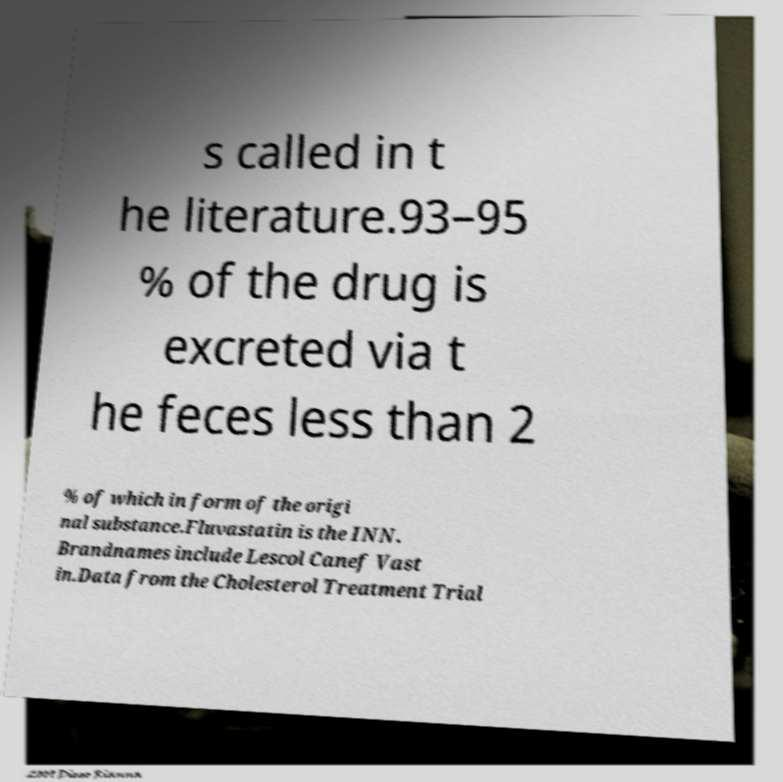I need the written content from this picture converted into text. Can you do that? s called in t he literature.93–95 % of the drug is excreted via t he feces less than 2 % of which in form of the origi nal substance.Fluvastatin is the INN. Brandnames include Lescol Canef Vast in.Data from the Cholesterol Treatment Trial 